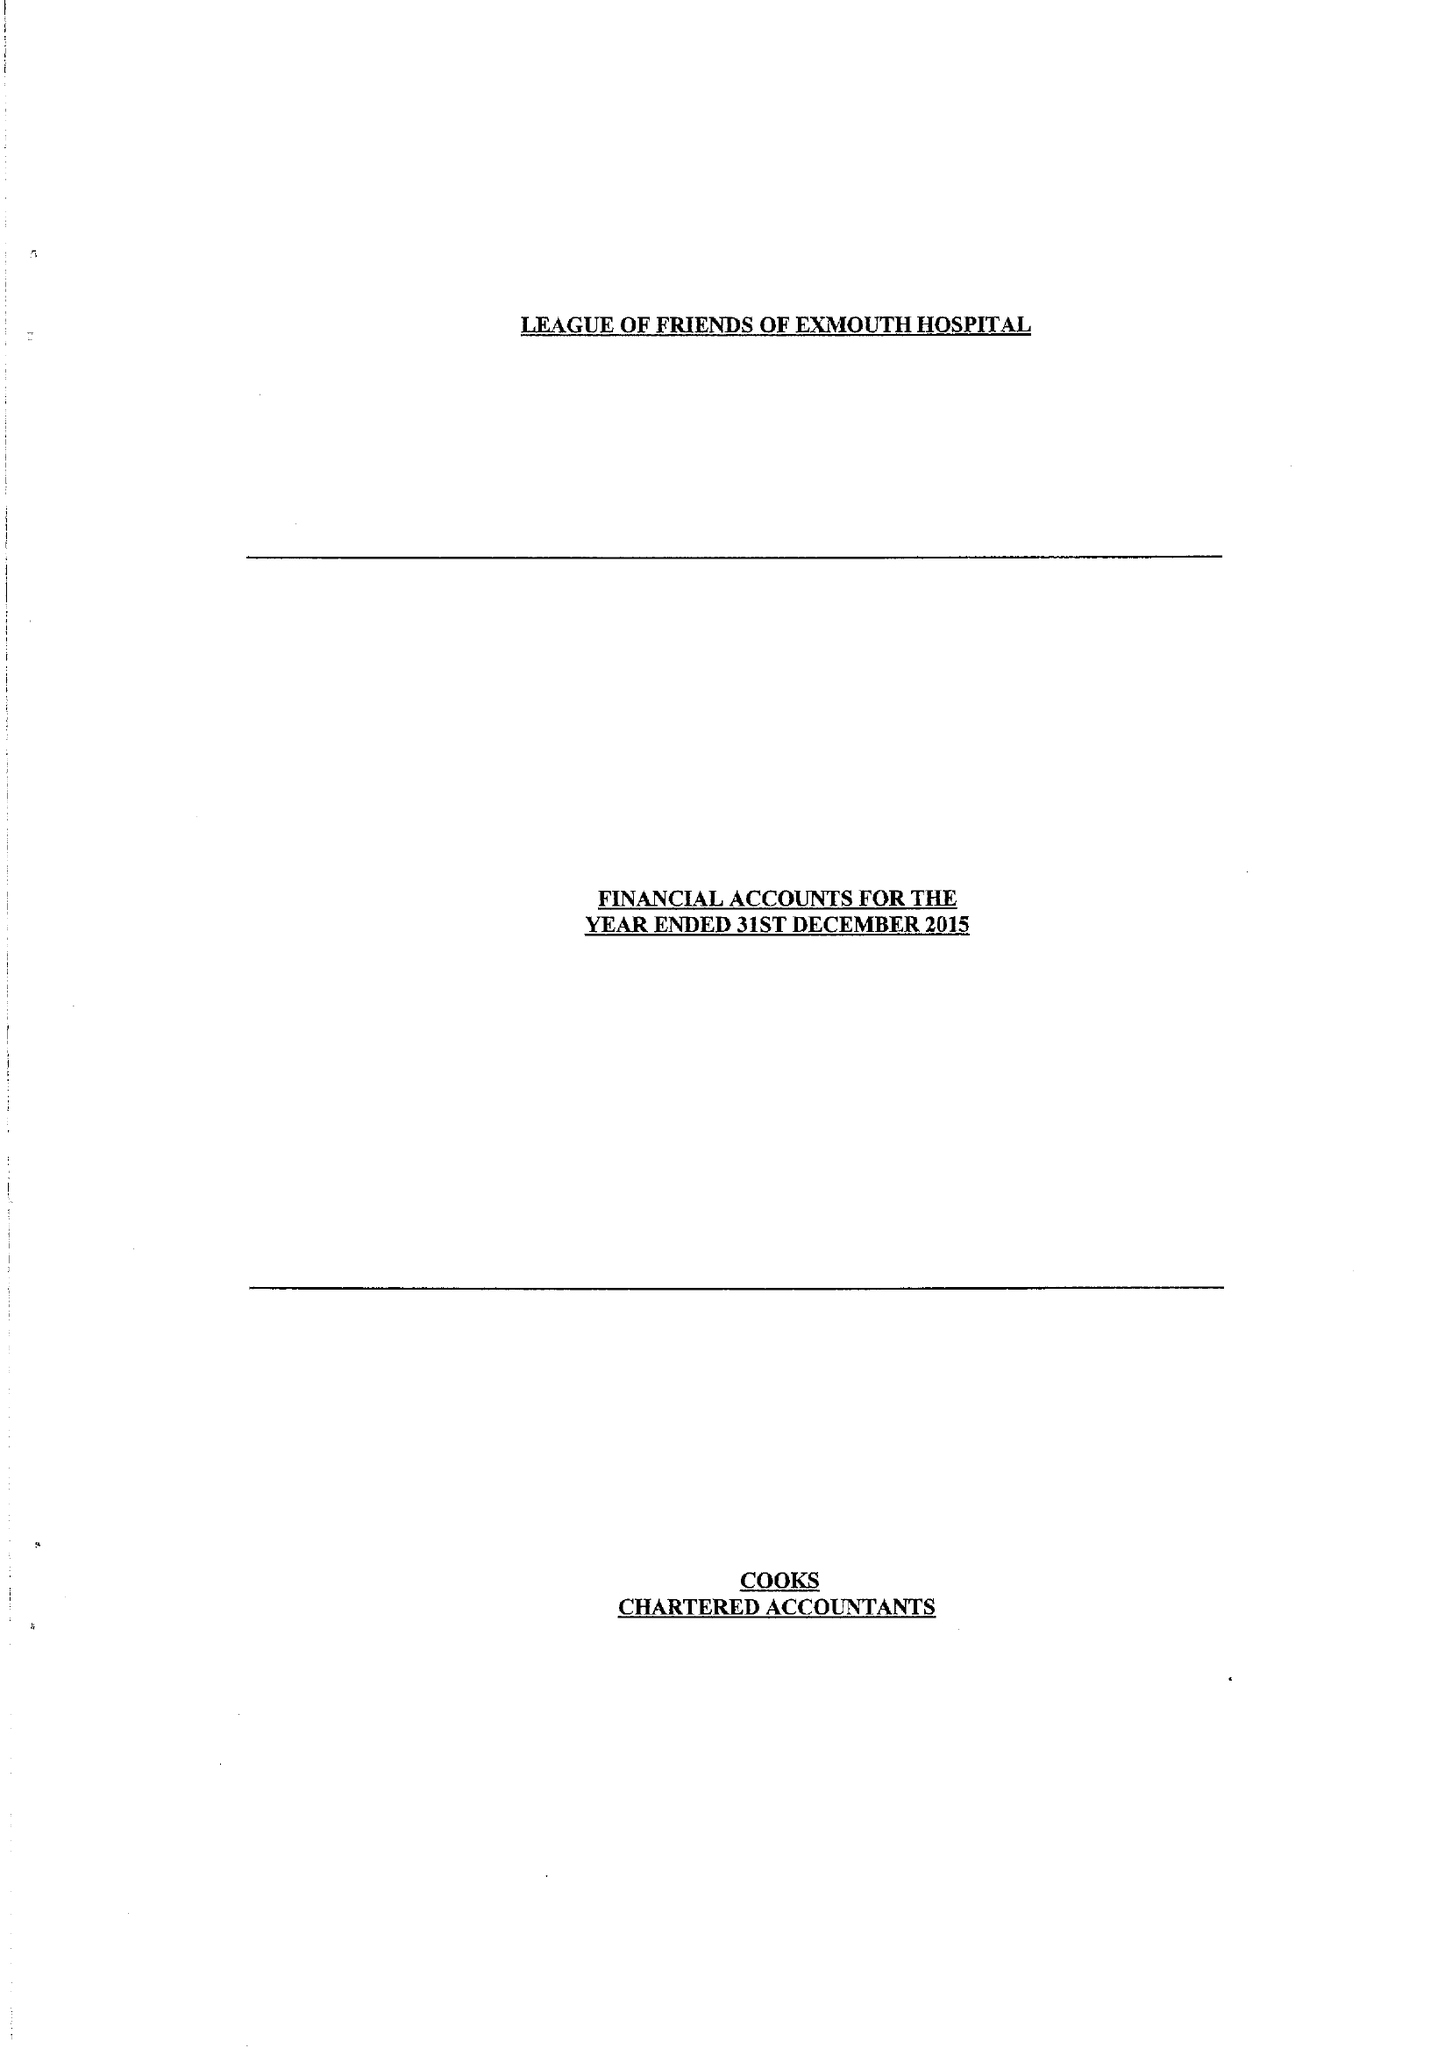What is the value for the address__post_town?
Answer the question using a single word or phrase. EXMOUTH 